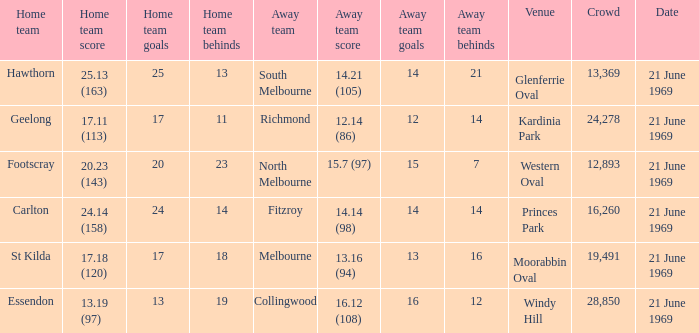What is Essendon's home team that has an away crowd size larger than 19,491? Collingwood. 